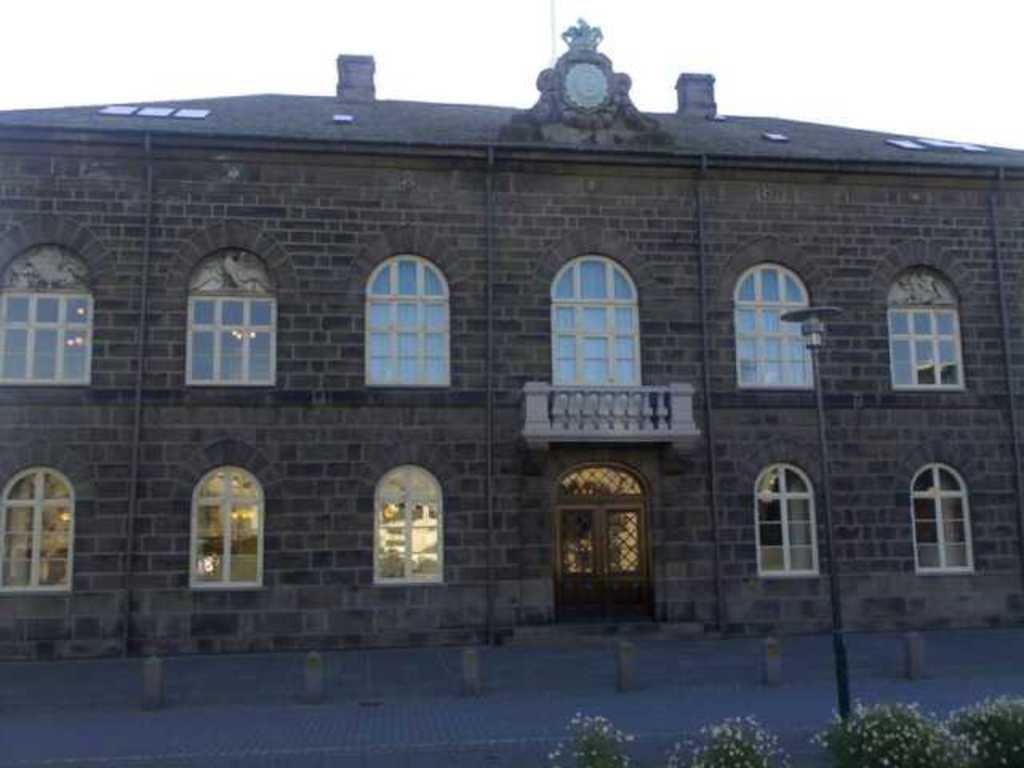What type of structure is present in the image? There is a building in the image. What are some features of the building? The building has doors and windows. Are there any natural elements in the image? Yes, there are plants and flowers in the image. What else can be seen in the image? There is a pole and a road in the image. What is visible in the background of the image? The sky is visible in the background of the image. Where is the jewel placed in the image? There is no jewel present in the image. What type of hook is used to hang the vase in the image? There is no vase or hook present in the image. 